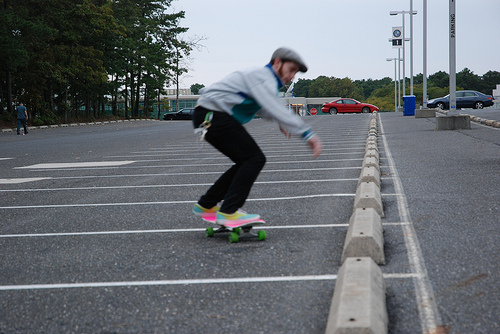Describe the setting where the skateboarding is taking place. The skateboarding is taking place in a spacious parking lot, which is mostly empty with visible parking lines and a few cars in the distance. It appears to be an overcast day providing even, soft lighting. 